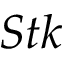<formula> <loc_0><loc_0><loc_500><loc_500>S t k</formula> 